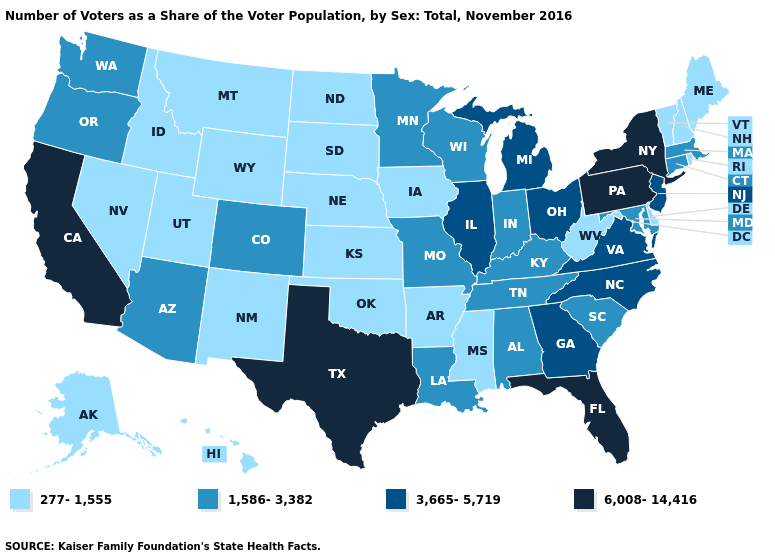What is the value of Montana?
Keep it brief. 277-1,555. Among the states that border Washington , does Idaho have the lowest value?
Short answer required. Yes. What is the value of Tennessee?
Answer briefly. 1,586-3,382. Does Washington have a higher value than Arkansas?
Short answer required. Yes. What is the value of New York?
Give a very brief answer. 6,008-14,416. What is the lowest value in the South?
Be succinct. 277-1,555. Which states have the highest value in the USA?
Short answer required. California, Florida, New York, Pennsylvania, Texas. Does West Virginia have the lowest value in the South?
Short answer required. Yes. What is the value of North Carolina?
Write a very short answer. 3,665-5,719. What is the value of Arizona?
Quick response, please. 1,586-3,382. What is the value of North Dakota?
Be succinct. 277-1,555. Name the states that have a value in the range 277-1,555?
Short answer required. Alaska, Arkansas, Delaware, Hawaii, Idaho, Iowa, Kansas, Maine, Mississippi, Montana, Nebraska, Nevada, New Hampshire, New Mexico, North Dakota, Oklahoma, Rhode Island, South Dakota, Utah, Vermont, West Virginia, Wyoming. Which states hav the highest value in the West?
Be succinct. California. Does New Mexico have the highest value in the USA?
Write a very short answer. No. 